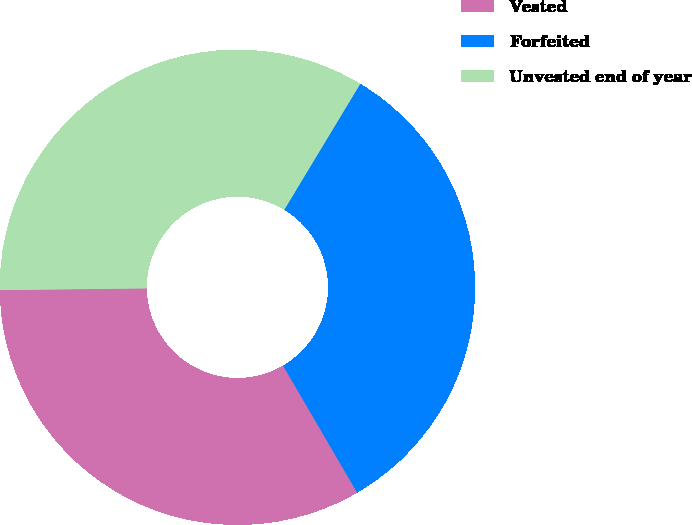<chart> <loc_0><loc_0><loc_500><loc_500><pie_chart><fcel>Vested<fcel>Forfeited<fcel>Unvested end of year<nl><fcel>33.22%<fcel>32.95%<fcel>33.83%<nl></chart> 